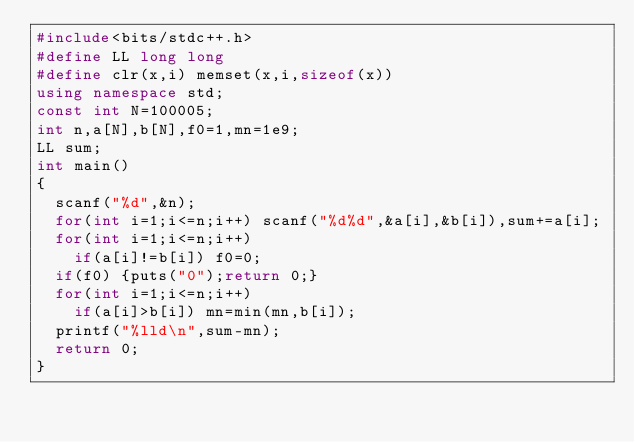<code> <loc_0><loc_0><loc_500><loc_500><_C++_>#include<bits/stdc++.h>
#define LL long long
#define clr(x,i) memset(x,i,sizeof(x))
using namespace std;
const int N=100005;
int n,a[N],b[N],f0=1,mn=1e9;
LL sum;
int main()
{
	scanf("%d",&n);
	for(int i=1;i<=n;i++) scanf("%d%d",&a[i],&b[i]),sum+=a[i];
	for(int i=1;i<=n;i++)
	  if(a[i]!=b[i]) f0=0;
	if(f0) {puts("0");return 0;}
	for(int i=1;i<=n;i++)
	  if(a[i]>b[i]) mn=min(mn,b[i]);
	printf("%lld\n",sum-mn);
	return 0;
}</code> 